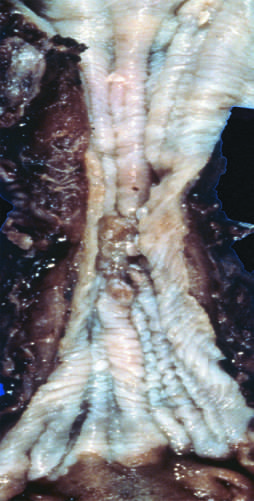s squamous cell carcinoma found in the mid-esophagus, where it commonly causes strictures?
Answer the question using a single word or phrase. Yes 